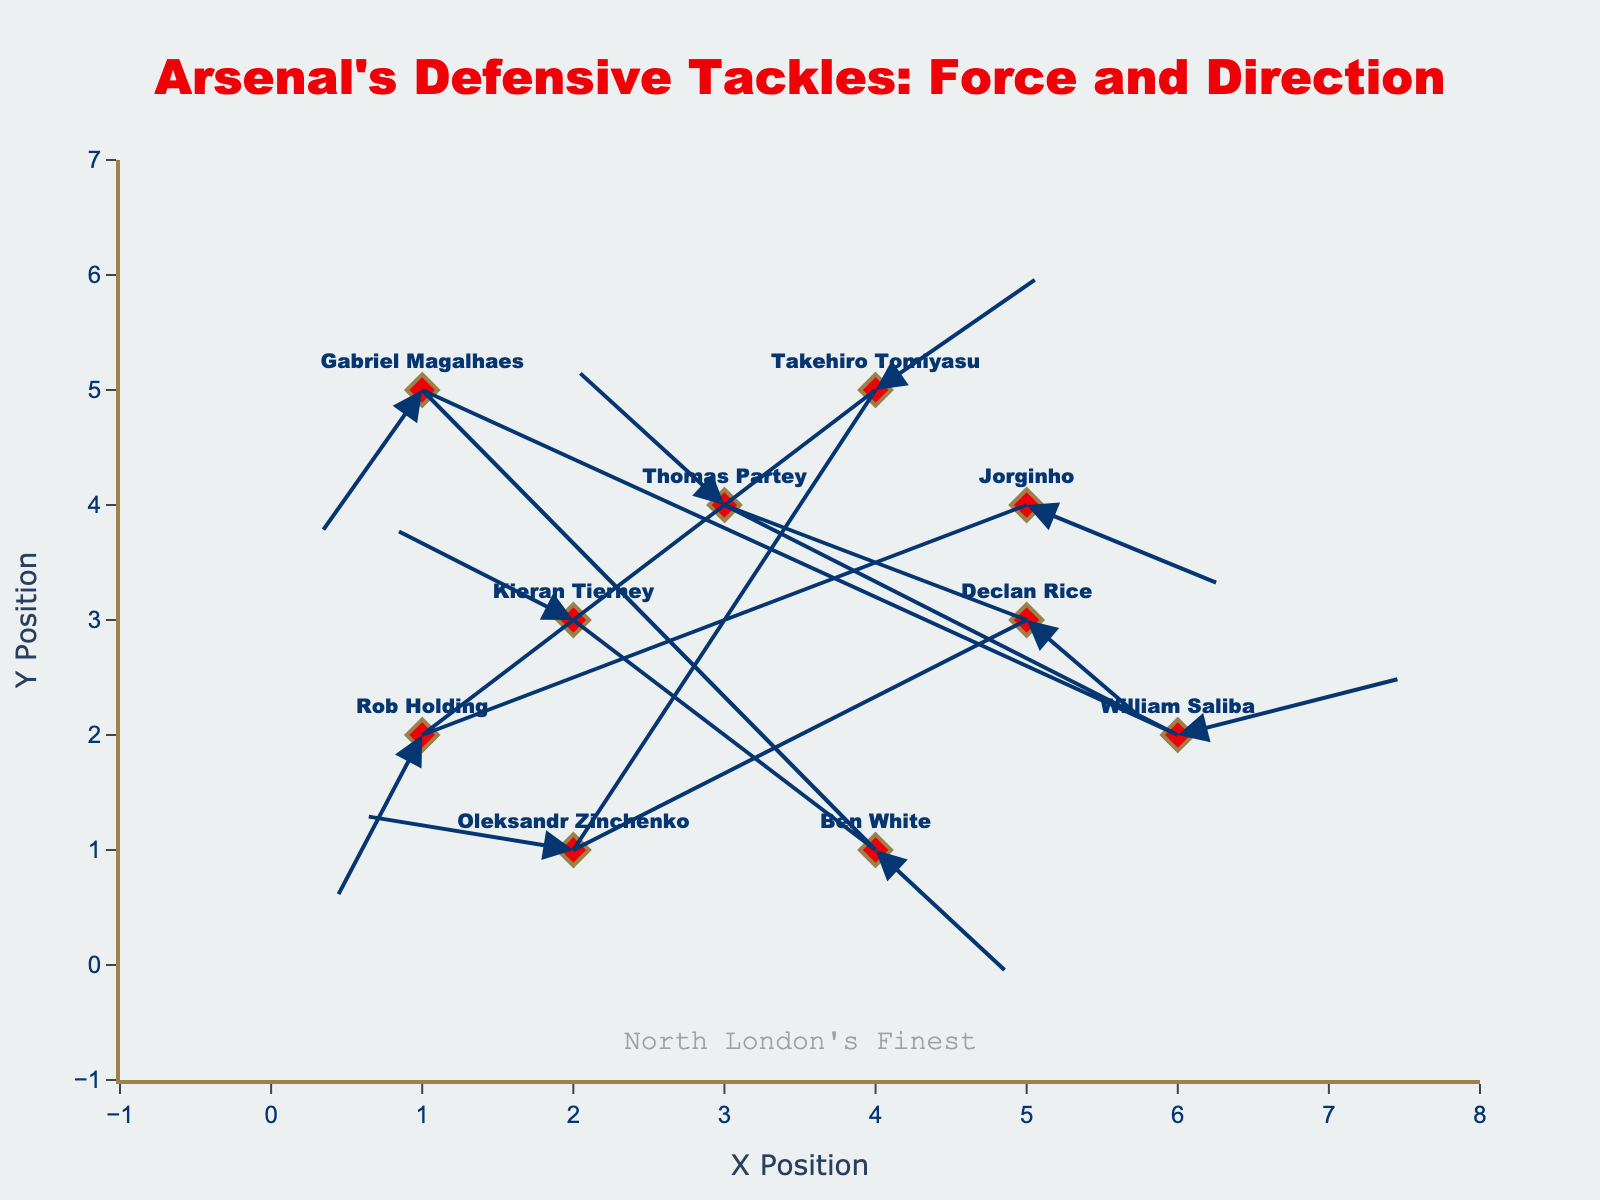What's the title of the plot? The title is displayed prominently at the top center of the plot. It reads "Arsenal's Defensive Tackles: Force and Direction".
Answer: Arsenal's Defensive Tackles: Force and Direction What are the x and y-axis titles? The x-axis title is "X Position" and the y-axis title is "Y Position". These titles are shown along the respective axes.
Answer: X Position and Y Position Which player has the highest positive x-direction force of tackle? Examine the u values (x-direction force) for all players. William Saliba has the highest positive x-direction force with a u value of 1.5.
Answer: William Saliba Who has the longest tackle vector? Calculate the length of each vector using the formula sqrt(u^2 + v^2). William Saliba's vector, with u=1.5 and v=0.5, has the length sqrt(1.5^2 + 0.5^2) = sqrt(2.25 + 0.25) = sqrt(2.5) ≈ 1.58, which is the longest.
Answer: William Saliba How many players have a negative y-direction force? Check the v values for negative values. The players with negative y-direction force are Ben White, Gabriel Magalhaes, Declan Rice, and Rob Holding.
Answer: 4 Which player has the tackle direction closest to the positive x-axis? The angle each vector makes with the positive x-axis is given by arctan(v/u). William Saliba's vector has u=1.5 and v=0.5, making the angle arctan(0.5/1.5) ≈ 18.4 degrees, which is closest to the positive x-axis.
Answer: William Saliba Compare the direction of tackles of Thomas Partey and Takehiro Tomiyasu. Who's direction is more upwards? Compare their v values. Thomas Partey has a v value of 1.2, while Takehiro Tomiyasu has a v value of 1.0. Thomas Partey's tackle direction is more upwards since 1.2 > 1.0.
Answer: Thomas Partey What is the range of the x-coordinates for the tackles? Identify the minimum and maximum x values. The minimum x value is 1 and the maximum x value is 6. Therefore, the range is from 1 to 6.
Answer: 1 to 6 Who has the most downward tackle force? Look for the most negative v value. Rob Holding has the lowest v value of -1.5, indicating the most downward force.
Answer: Rob Holding 